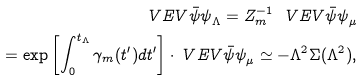Convert formula to latex. <formula><loc_0><loc_0><loc_500><loc_500>\ V E V { \bar { \psi } \psi } _ { \Lambda } = Z _ { m } ^ { - 1 } \ V E V { \bar { \psi } \psi } _ { \mu } \\ = \exp \left [ \int _ { 0 } ^ { t _ { \Lambda } } \gamma _ { m } ( t ^ { \prime } ) d t ^ { \prime } \right ] \cdot \ V E V { \bar { \psi } \psi } _ { \mu } \simeq - \Lambda ^ { 2 } \Sigma ( \Lambda ^ { 2 } ) ,</formula> 